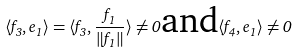<formula> <loc_0><loc_0><loc_500><loc_500>\langle f _ { 3 } , e _ { 1 } \rangle = \langle f _ { 3 } , \frac { f _ { 1 } } { \| f _ { 1 } \| } \rangle \neq 0 \text {and} \langle f _ { 4 } , e _ { 1 } \rangle \neq 0</formula> 